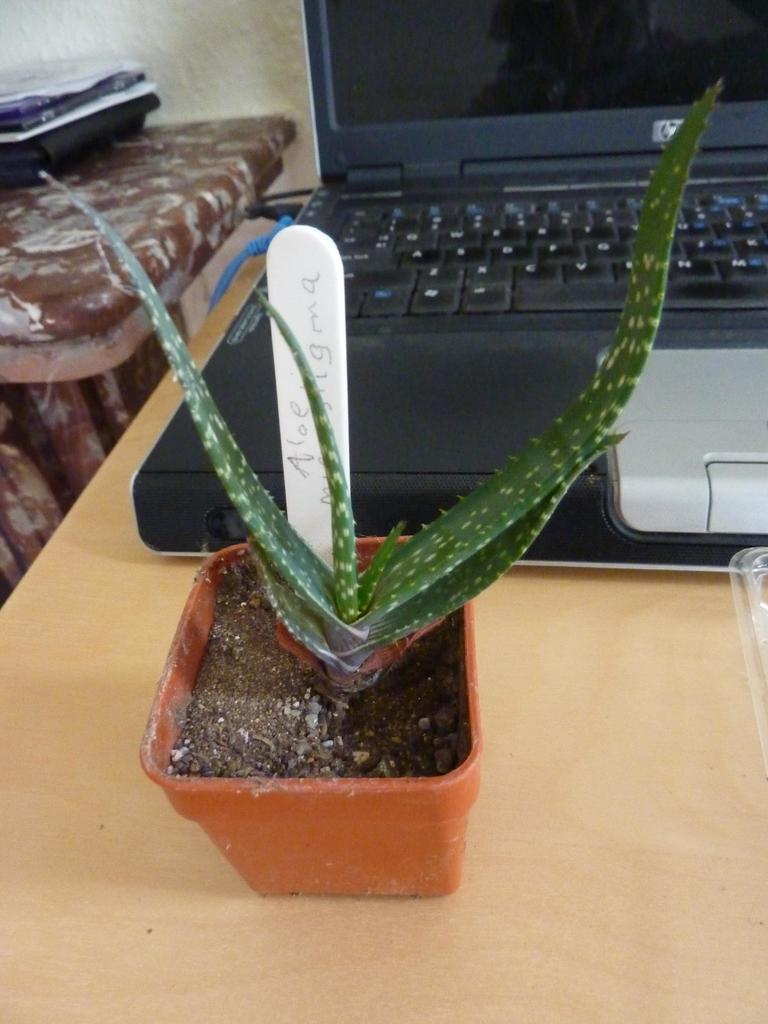Describe this image in one or two sentences. In this image we can see a laptop and a plant in a pot which are placed on a table. We can also see some objects beside it. 